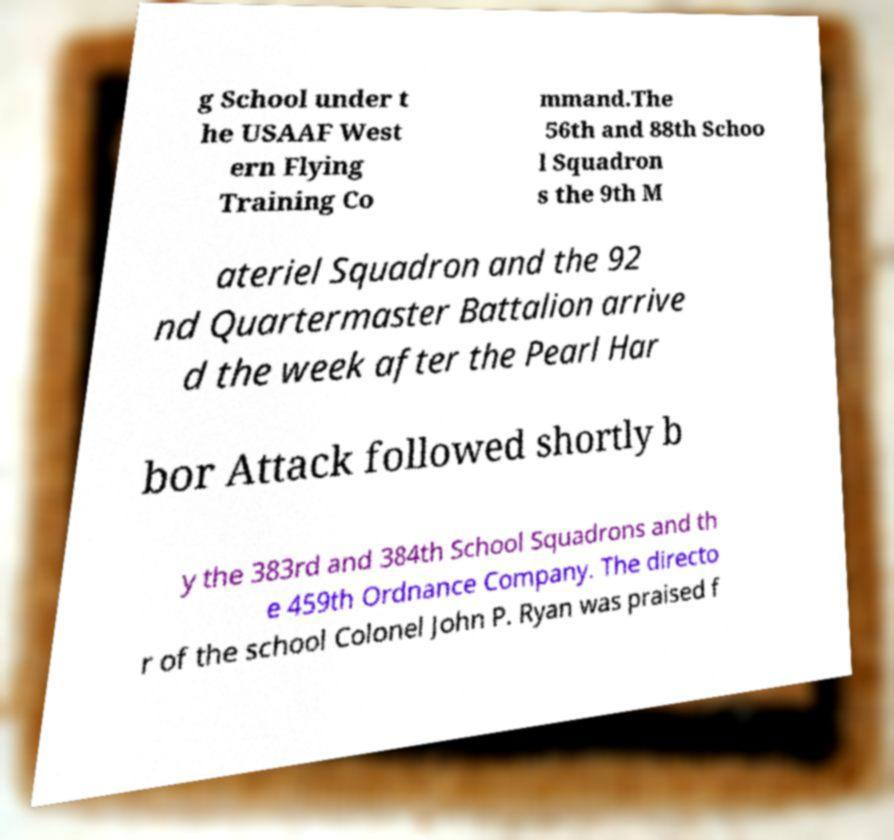For documentation purposes, I need the text within this image transcribed. Could you provide that? g School under t he USAAF West ern Flying Training Co mmand.The 56th and 88th Schoo l Squadron s the 9th M ateriel Squadron and the 92 nd Quartermaster Battalion arrive d the week after the Pearl Har bor Attack followed shortly b y the 383rd and 384th School Squadrons and th e 459th Ordnance Company. The directo r of the school Colonel John P. Ryan was praised f 